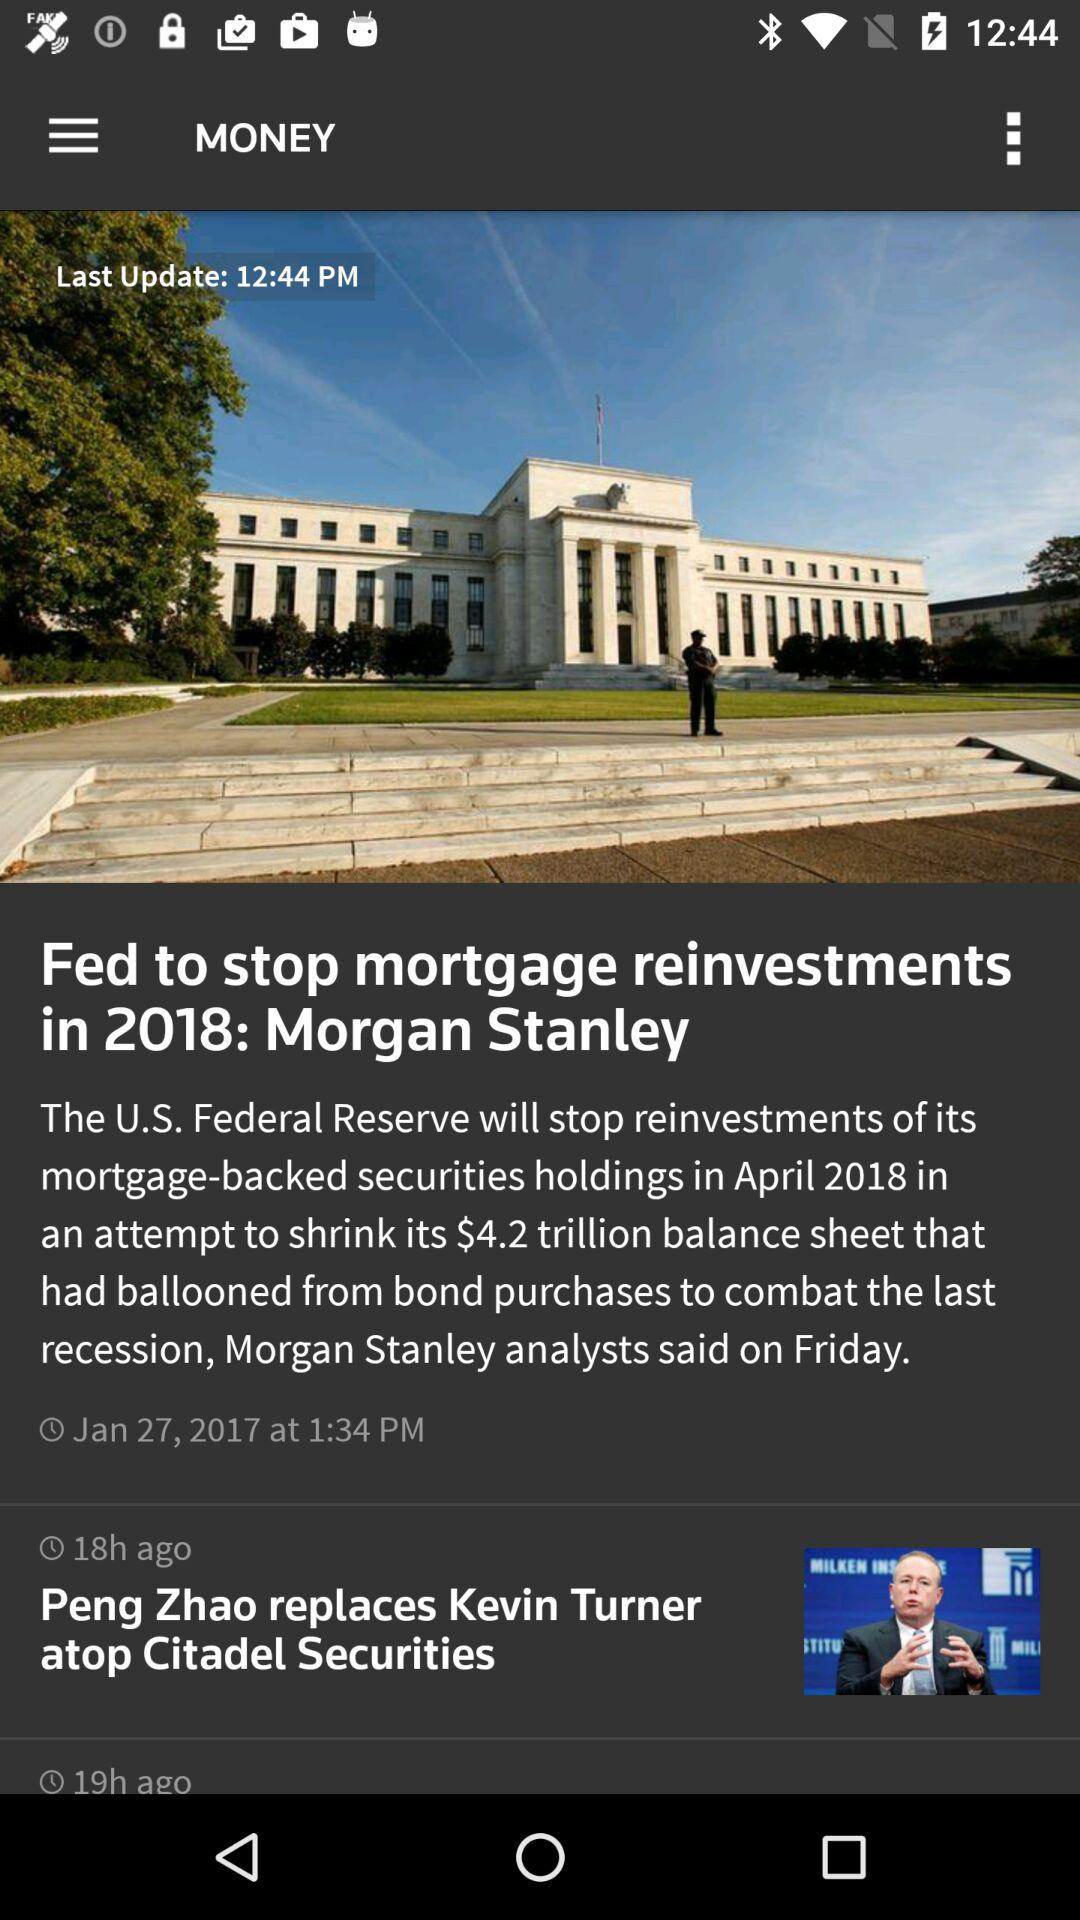What news was posted 18 hours ago? The news that was posted 18 hours ago was "Peng Zhao replaces Kevin Turner atop Citadel Securities". 